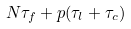Convert formula to latex. <formula><loc_0><loc_0><loc_500><loc_500>N \tau _ { f } + p ( \tau _ { l } + \tau _ { c } )</formula> 